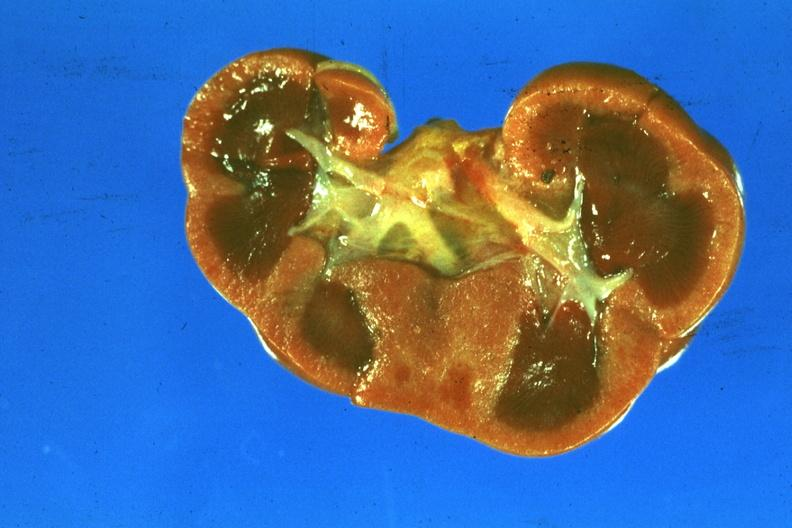what is present?
Answer the question using a single word or phrase. Ischemia newborn 